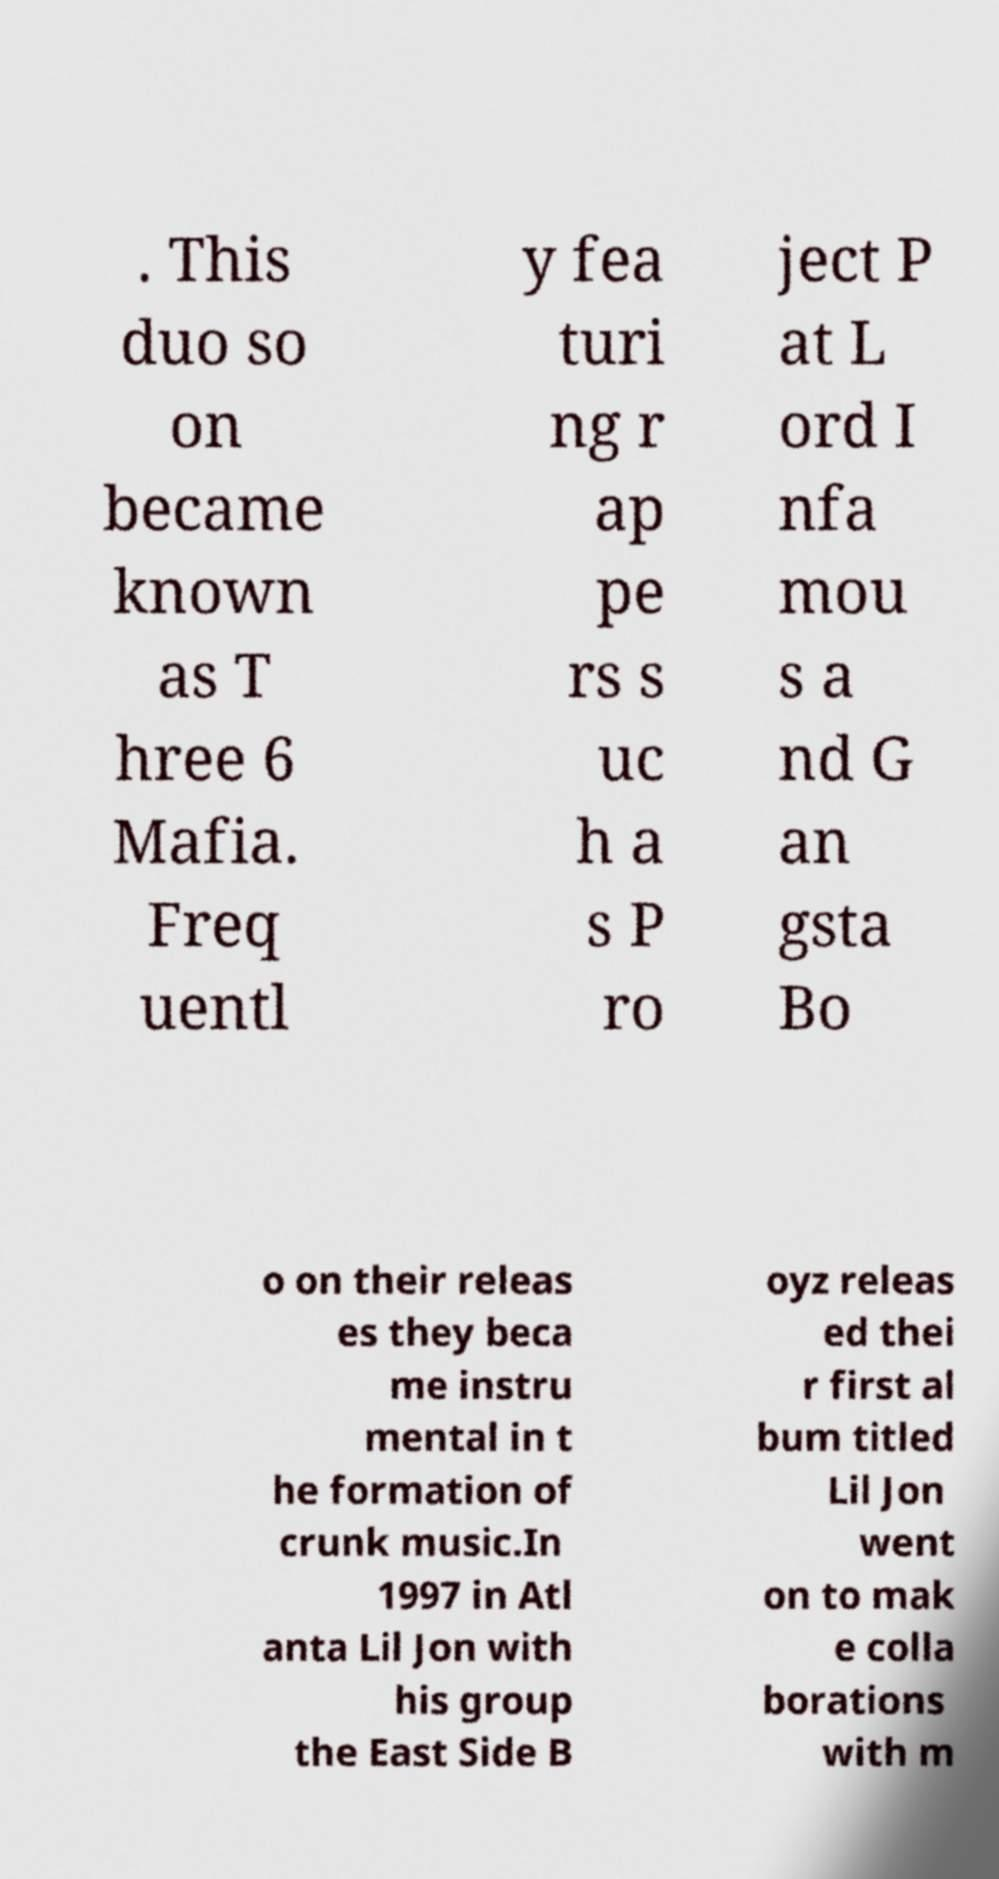Could you extract and type out the text from this image? . This duo so on became known as T hree 6 Mafia. Freq uentl y fea turi ng r ap pe rs s uc h a s P ro ject P at L ord I nfa mou s a nd G an gsta Bo o on their releas es they beca me instru mental in t he formation of crunk music.In 1997 in Atl anta Lil Jon with his group the East Side B oyz releas ed thei r first al bum titled Lil Jon went on to mak e colla borations with m 